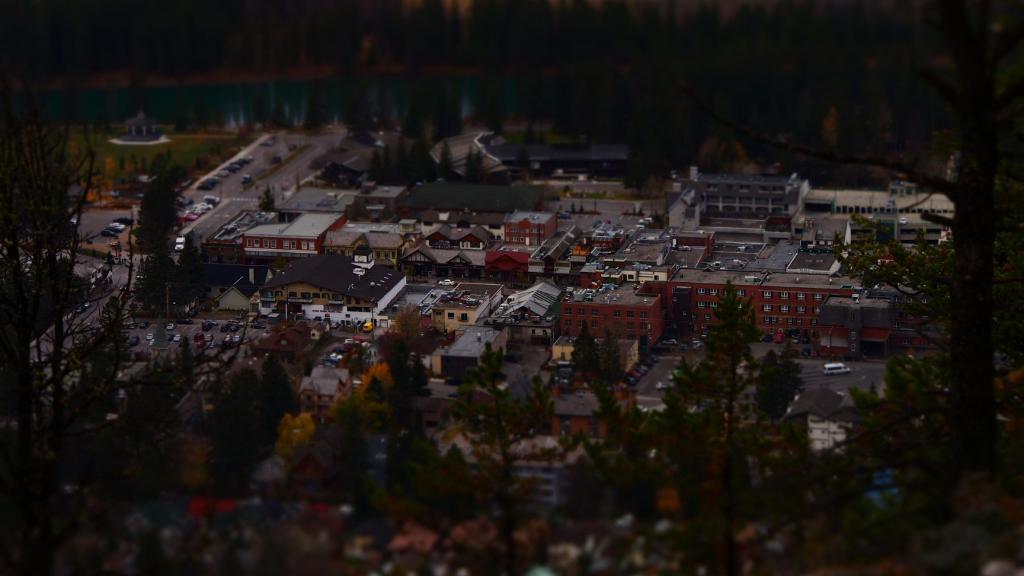Can you describe this image briefly? In this image we can see there are some buildings, trees and some vehicles on the road. At the top of the image there is water. 